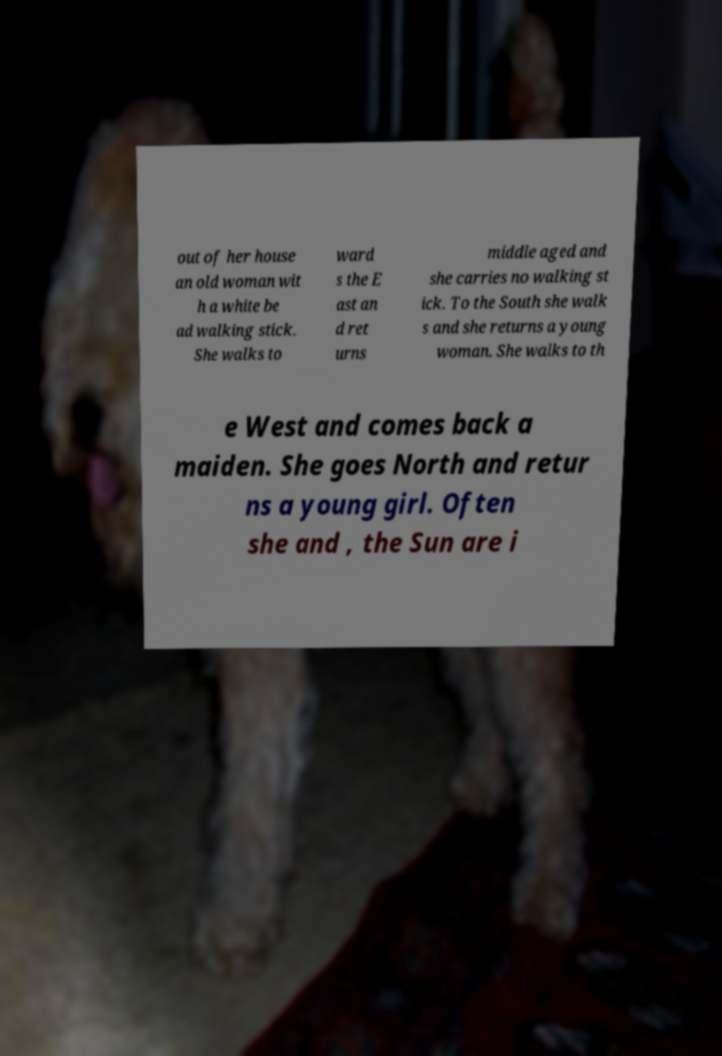For documentation purposes, I need the text within this image transcribed. Could you provide that? out of her house an old woman wit h a white be ad walking stick. She walks to ward s the E ast an d ret urns middle aged and she carries no walking st ick. To the South she walk s and she returns a young woman. She walks to th e West and comes back a maiden. She goes North and retur ns a young girl. Often she and , the Sun are i 